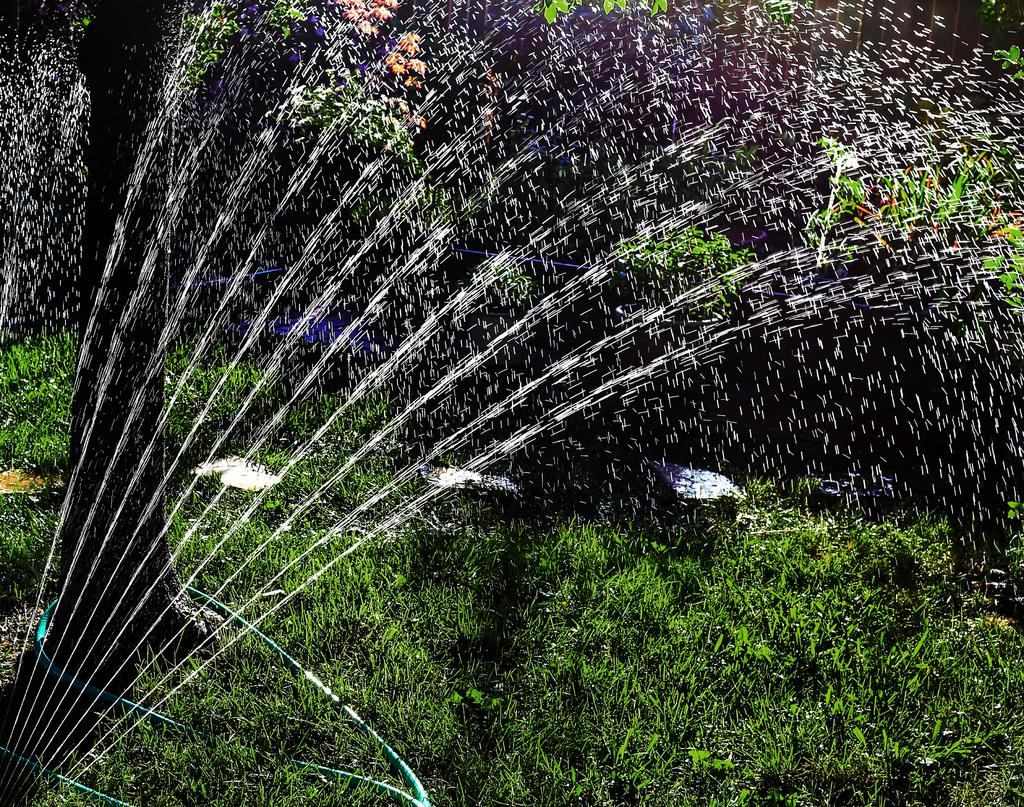What type of vegetation can be seen in the image? There are plants and a tree in the image. What type of ground cover is present in the image? There is grass in the image. What natural element is visible in the image? Water is visible in the image. What color is the hen's comb in the image? There is no hen present in the image. How does the light affect the plants in the image? The provided facts do not mention any light source or its effect on the plants. 